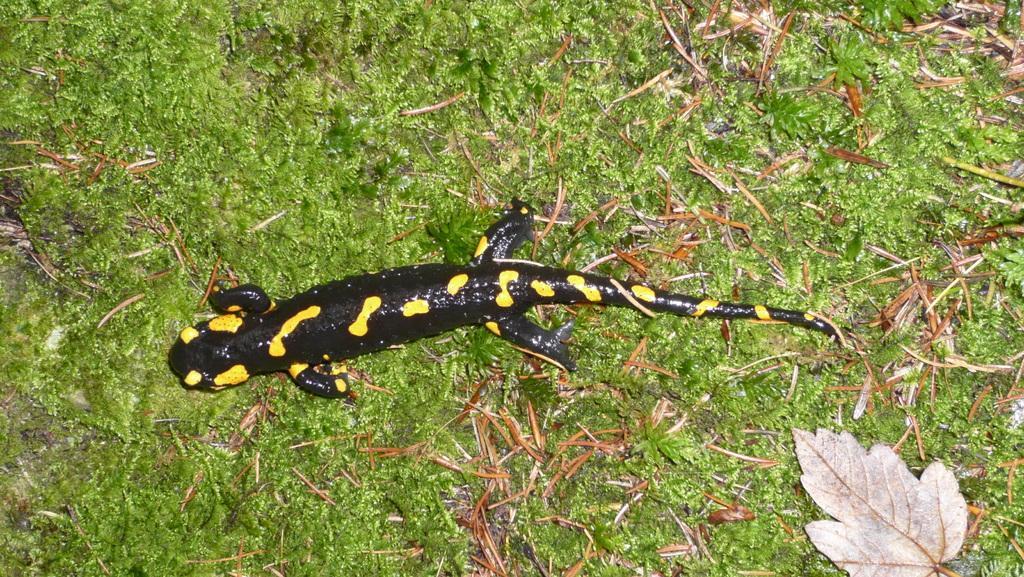Could you give a brief overview of what you see in this image? In this image there is a reptile on the grassland having few dried leaves and plants. 